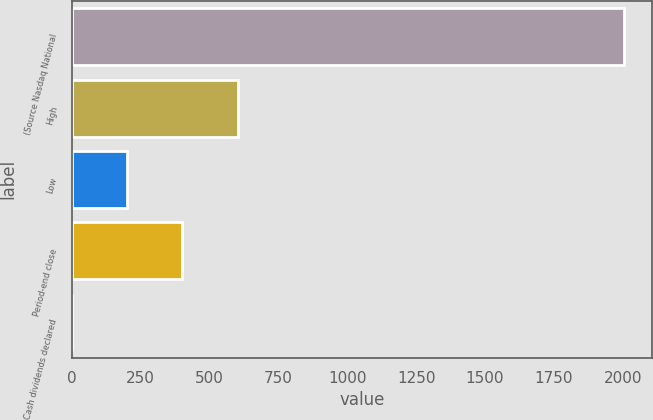Convert chart to OTSL. <chart><loc_0><loc_0><loc_500><loc_500><bar_chart><fcel>(Source Nasdaq National<fcel>High<fcel>Low<fcel>Period-end close<fcel>Cash dividends declared<nl><fcel>2005<fcel>601.71<fcel>200.77<fcel>401.24<fcel>0.3<nl></chart> 